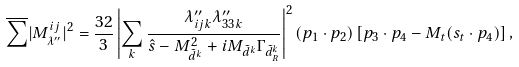<formula> <loc_0><loc_0><loc_500><loc_500>\overline { \sum } | M _ { \lambda ^ { \prime \prime } } ^ { i j } | ^ { 2 } = \frac { 3 2 } { 3 } \left | \sum _ { k } \frac { \lambda _ { i j k } ^ { \prime \prime } \lambda _ { 3 3 k } ^ { \prime \prime } } { \hat { s } - M _ { \tilde { d } ^ { k } } ^ { 2 } + i M _ { \tilde { d } ^ { k } } \Gamma _ { \tilde { d } _ { R } ^ { k } } } \right | ^ { 2 } ( p _ { 1 } \cdot p _ { 2 } ) \left [ p _ { 3 } \cdot p _ { 4 } - M _ { t } ( s _ { t } \cdot p _ { 4 } ) \right ] ,</formula> 